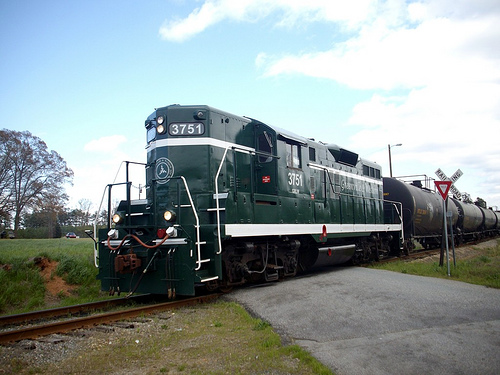<image>
Is there a sky behind the train? Yes. From this viewpoint, the sky is positioned behind the train, with the train partially or fully occluding the sky. Where is the train in relation to the sign? Is it in front of the sign? No. The train is not in front of the sign. The spatial positioning shows a different relationship between these objects. 